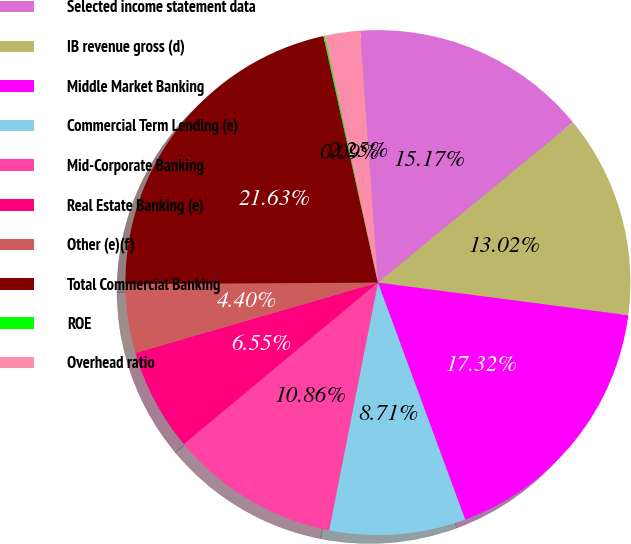Convert chart to OTSL. <chart><loc_0><loc_0><loc_500><loc_500><pie_chart><fcel>Selected income statement data<fcel>IB revenue gross (d)<fcel>Middle Market Banking<fcel>Commercial Term Lending (e)<fcel>Mid-Corporate Banking<fcel>Real Estate Banking (e)<fcel>Other (e)(f)<fcel>Total Commercial Banking<fcel>ROE<fcel>Overhead ratio<nl><fcel>15.17%<fcel>13.02%<fcel>17.32%<fcel>8.71%<fcel>10.86%<fcel>6.55%<fcel>4.4%<fcel>21.63%<fcel>0.09%<fcel>2.25%<nl></chart> 